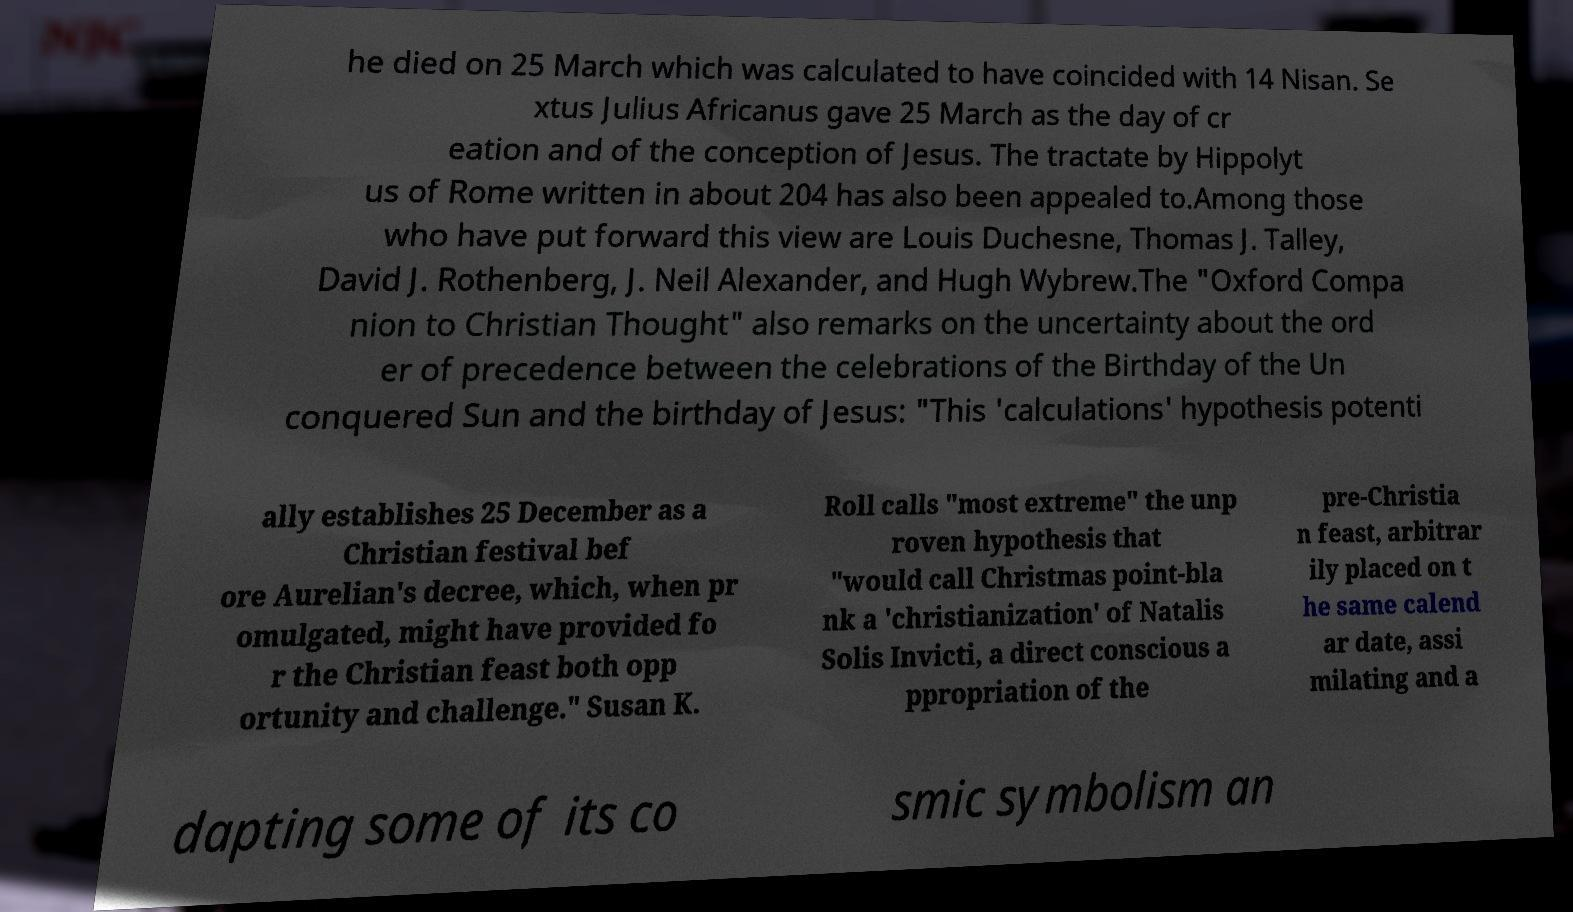Could you assist in decoding the text presented in this image and type it out clearly? he died on 25 March which was calculated to have coincided with 14 Nisan. Se xtus Julius Africanus gave 25 March as the day of cr eation and of the conception of Jesus. The tractate by Hippolyt us of Rome written in about 204 has also been appealed to.Among those who have put forward this view are Louis Duchesne, Thomas J. Talley, David J. Rothenberg, J. Neil Alexander, and Hugh Wybrew.The "Oxford Compa nion to Christian Thought" also remarks on the uncertainty about the ord er of precedence between the celebrations of the Birthday of the Un conquered Sun and the birthday of Jesus: "This 'calculations' hypothesis potenti ally establishes 25 December as a Christian festival bef ore Aurelian's decree, which, when pr omulgated, might have provided fo r the Christian feast both opp ortunity and challenge." Susan K. Roll calls "most extreme" the unp roven hypothesis that "would call Christmas point-bla nk a 'christianization' of Natalis Solis Invicti, a direct conscious a ppropriation of the pre-Christia n feast, arbitrar ily placed on t he same calend ar date, assi milating and a dapting some of its co smic symbolism an 